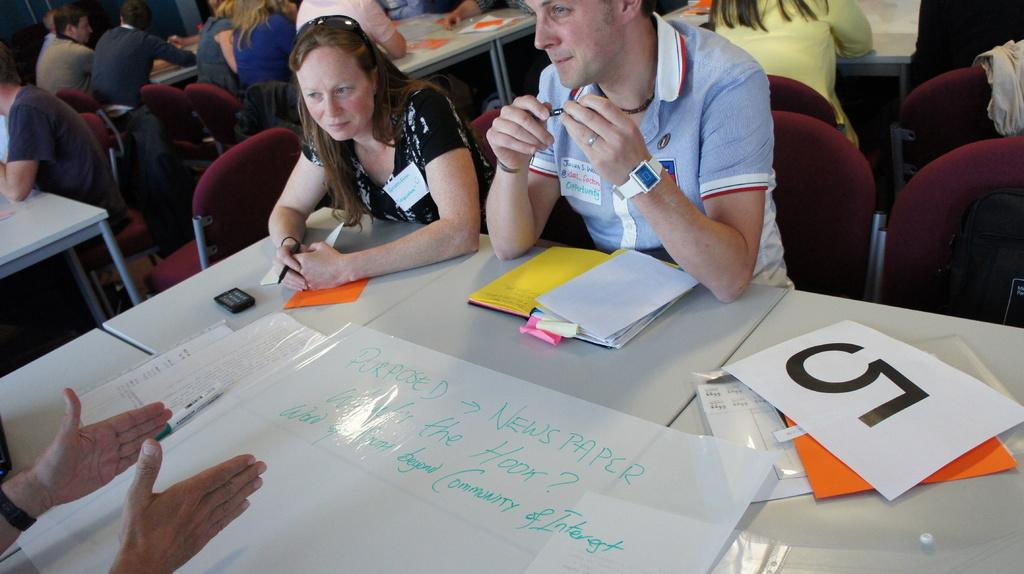How many people are in the image? There is a group of people in the image, but the exact number is not specified. What are the people doing in the image? The people are seated on chairs in the image. What items can be seen on the tables in front of the people? There are papers, books, and other things on the tables in front of the people. Which person's knee is causing a disturbance in the image? There is no mention of any knees or disturbances in the image; it only shows a group of people seated on chairs with items on the tables in front of them. 